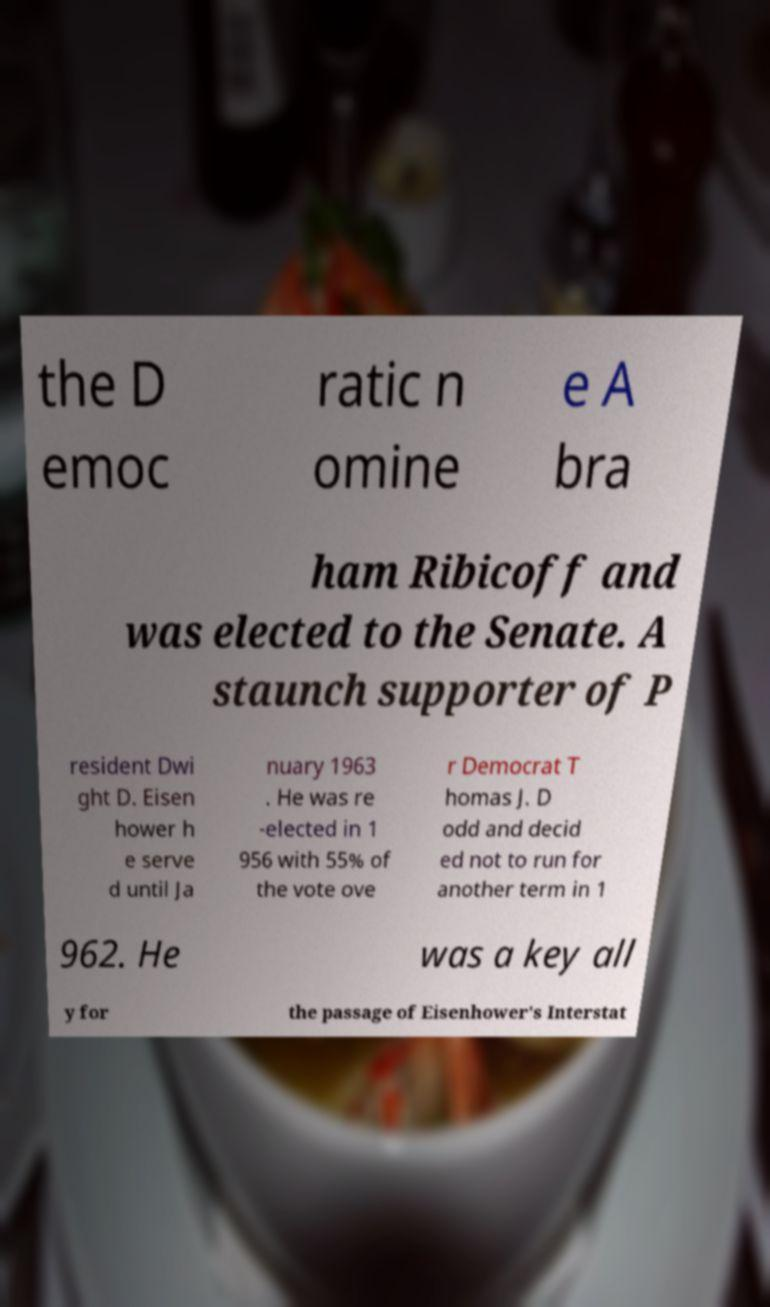There's text embedded in this image that I need extracted. Can you transcribe it verbatim? the D emoc ratic n omine e A bra ham Ribicoff and was elected to the Senate. A staunch supporter of P resident Dwi ght D. Eisen hower h e serve d until Ja nuary 1963 . He was re -elected in 1 956 with 55% of the vote ove r Democrat T homas J. D odd and decid ed not to run for another term in 1 962. He was a key all y for the passage of Eisenhower's Interstat 